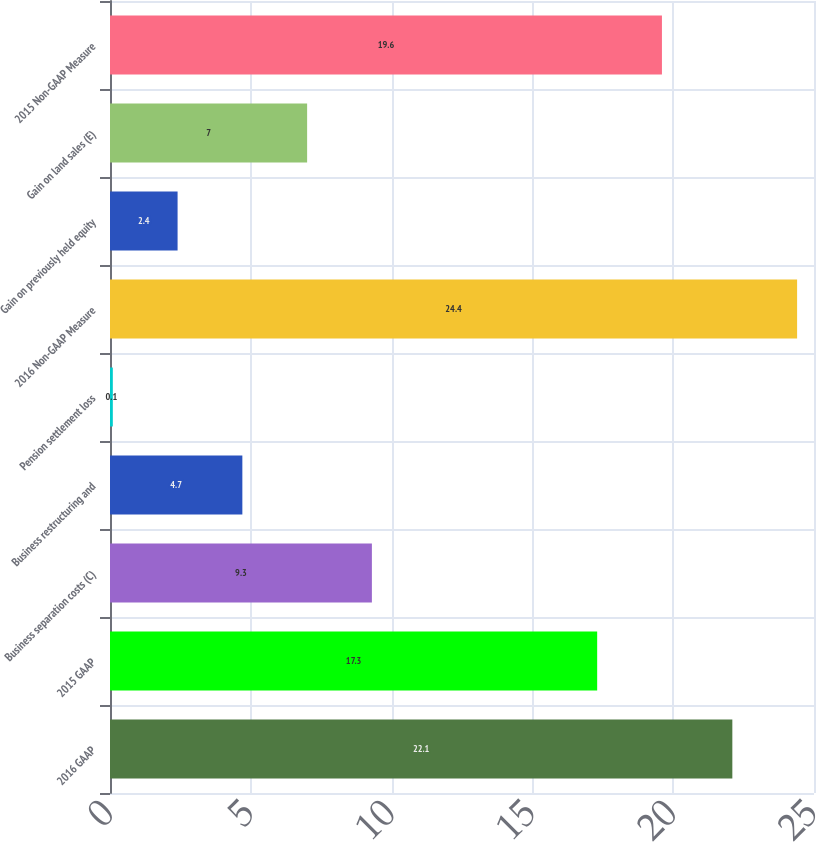Convert chart. <chart><loc_0><loc_0><loc_500><loc_500><bar_chart><fcel>2016 GAAP<fcel>2015 GAAP<fcel>Business separation costs (C)<fcel>Business restructuring and<fcel>Pension settlement loss<fcel>2016 Non-GAAP Measure<fcel>Gain on previously held equity<fcel>Gain on land sales (E)<fcel>2015 Non-GAAP Measure<nl><fcel>22.1<fcel>17.3<fcel>9.3<fcel>4.7<fcel>0.1<fcel>24.4<fcel>2.4<fcel>7<fcel>19.6<nl></chart> 